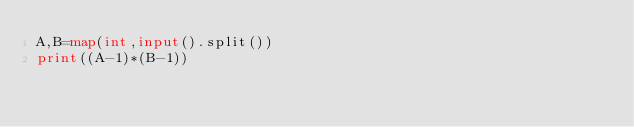<code> <loc_0><loc_0><loc_500><loc_500><_Python_>A,B=map(int,input().split())
print((A-1)*(B-1))</code> 